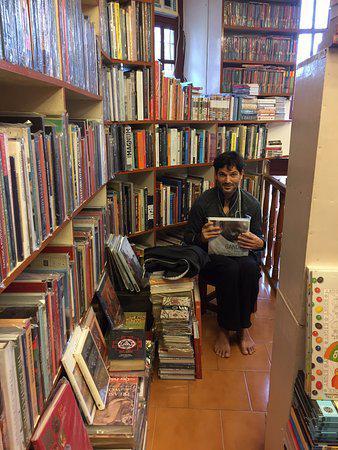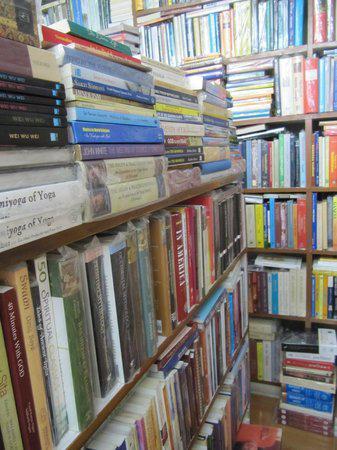The first image is the image on the left, the second image is the image on the right. Given the left and right images, does the statement "There is atleast two people in the photo" hold true? Answer yes or no. No. The first image is the image on the left, the second image is the image on the right. Analyze the images presented: Is the assertion "A person poses for their picture in the left image." valid? Answer yes or no. Yes. 